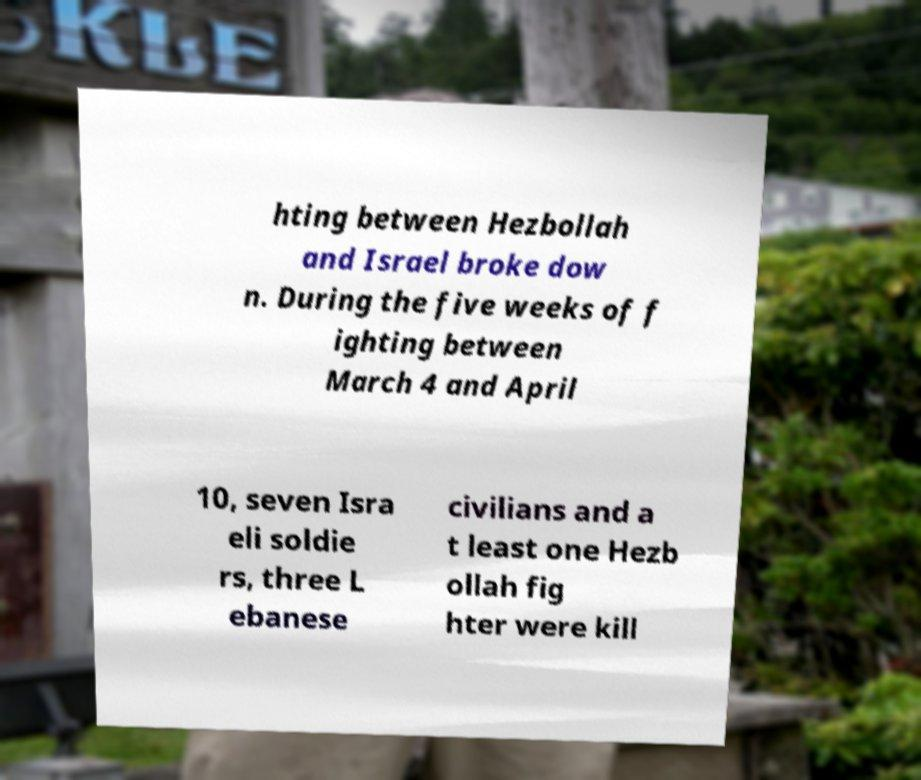Could you assist in decoding the text presented in this image and type it out clearly? hting between Hezbollah and Israel broke dow n. During the five weeks of f ighting between March 4 and April 10, seven Isra eli soldie rs, three L ebanese civilians and a t least one Hezb ollah fig hter were kill 